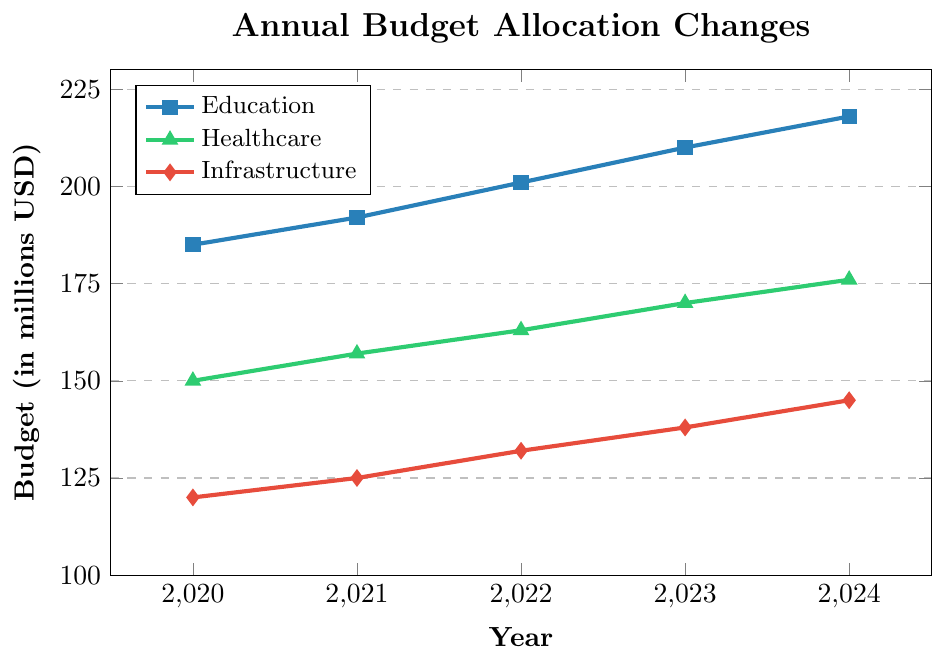What's the total budget allocated to education from 2020 to 2024? Add the budgets for each year from 2020 through 2024: 185 + 192 + 201 + 210 + 218 = 1006
Answer: 1006 million USD Which sector had the highest budget allocation in 2023? Compare the budgets in 2023: Education (210 million), Healthcare (170 million), Infrastructure (138 million). Education has the highest allocation.
Answer: Education What is the difference in the budget for healthcare between 2020 and 2024? Subtract the 2020 healthcare budget from the 2024 healthcare budget: 176 - 150 = 26
Answer: 26 million USD How much did the infrastructure budget increase from 2020 to 2023? Subtract the 2020 infrastructure budget from the 2023 infrastructure budget: 138 - 120 = 18
Answer: 18 million USD Which sector has shown the most consistent increase over the years? Observe the trend lines for each sector. Education, healthcare, and infrastructure all show consistent increases, but education has the steadiest and largest incremental change each year.
Answer: Education What is the average annual budget allocation for education over the five years? Calculate the average: (185 + 192 + 201 + 210 + 218) / 5 = 1006 / 5 = 201.2
Answer: 201.2 million USD By how much did the healthcare budget change between 2021 and 2023? Subtract the 2021 healthcare budget from the 2023 healthcare budget: 170 - 157 = 13
Answer: 13 million USD Out of Education, Healthcare, and Infrastructure, which one had the smallest budget allocation in 2022? Compare the budgets in 2022: Education (201 million), Healthcare (163 million), Infrastructure (132 million). Infrastructure has the smallest allocation.
Answer: Infrastructure What is the combined budget allocation for all three sectors in 2024? Add the budgets of all sectors in 2024: 218 (Education) + 176 (Healthcare) + 145 (Infrastructure) = 539
Answer: 539 million USD Between 2020 and 2024, which sector saw the highest overall increase in budget allocation? Calculate the increase for each sector: Education (218-185 = 33), Healthcare (176-150 = 26), Infrastructure (145-120 = 25). Education saw the highest increase.
Answer: Education 